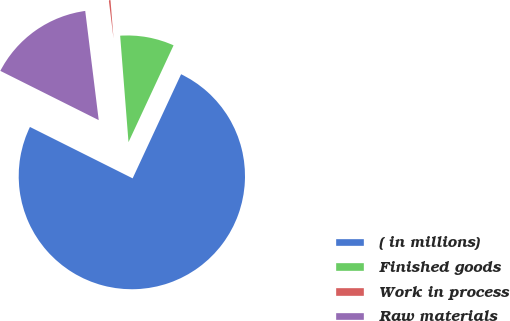<chart> <loc_0><loc_0><loc_500><loc_500><pie_chart><fcel>( in millions)<fcel>Finished goods<fcel>Work in process<fcel>Raw materials<nl><fcel>75.46%<fcel>8.18%<fcel>0.71%<fcel>15.66%<nl></chart> 